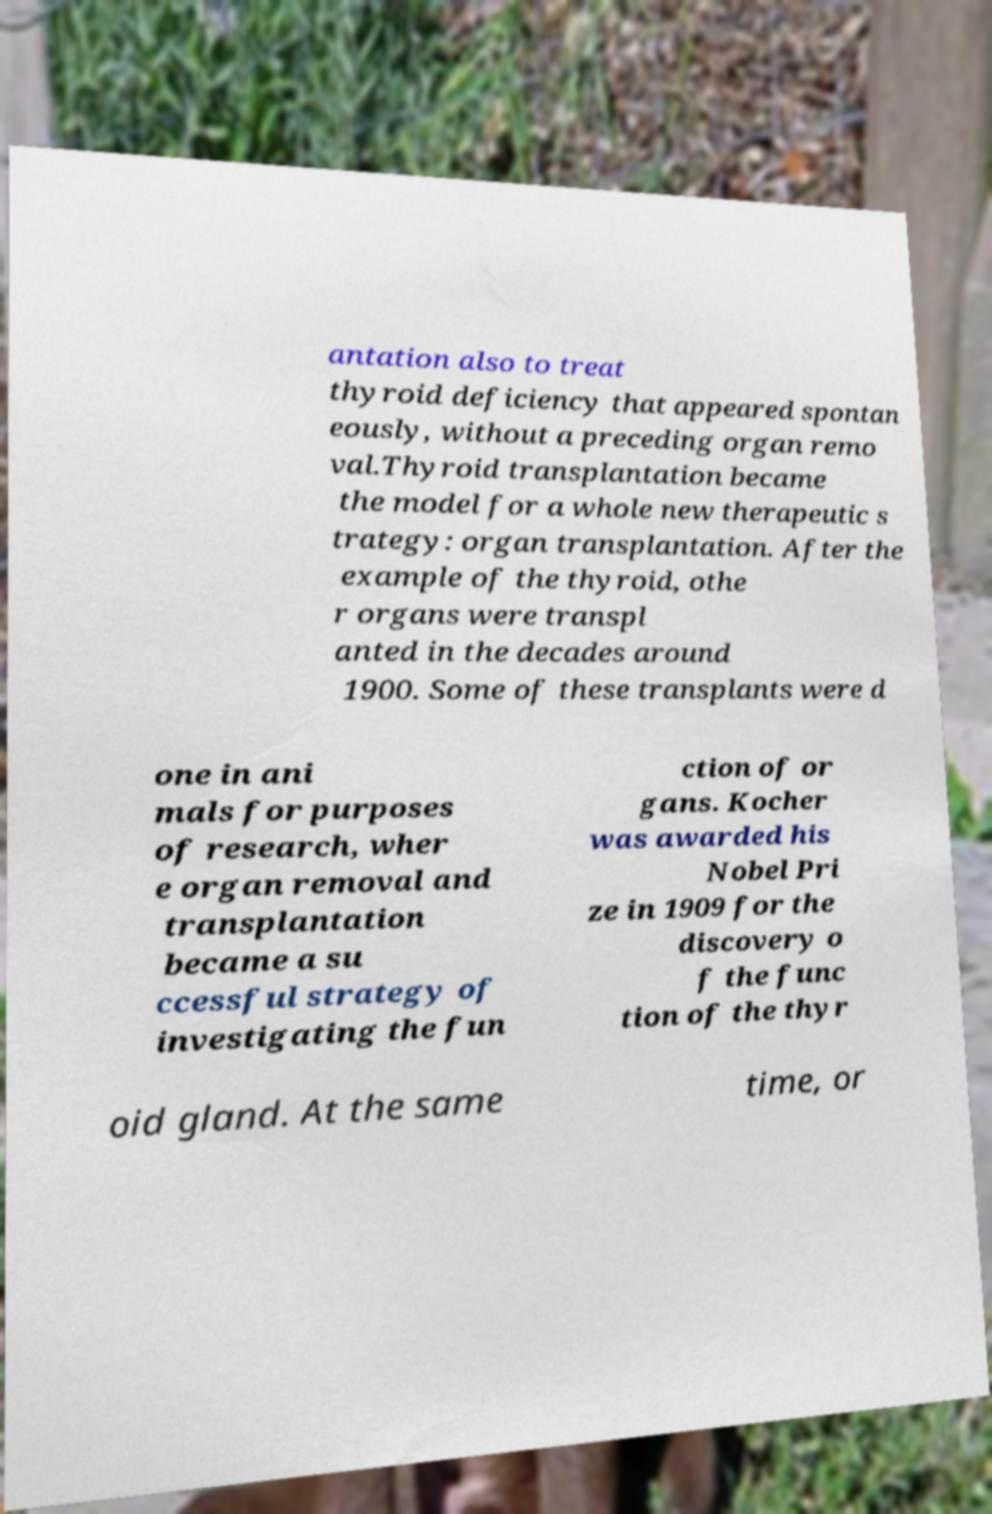Could you assist in decoding the text presented in this image and type it out clearly? antation also to treat thyroid deficiency that appeared spontan eously, without a preceding organ remo val.Thyroid transplantation became the model for a whole new therapeutic s trategy: organ transplantation. After the example of the thyroid, othe r organs were transpl anted in the decades around 1900. Some of these transplants were d one in ani mals for purposes of research, wher e organ removal and transplantation became a su ccessful strategy of investigating the fun ction of or gans. Kocher was awarded his Nobel Pri ze in 1909 for the discovery o f the func tion of the thyr oid gland. At the same time, or 